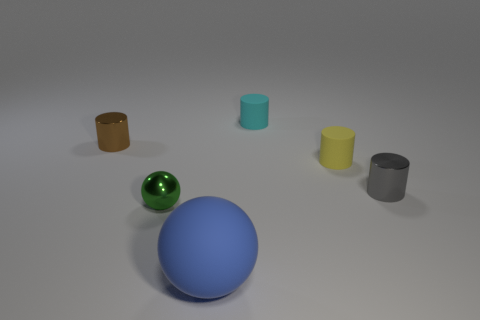Add 4 green objects. How many objects exist? 10 Subtract all spheres. How many objects are left? 4 Add 1 tiny gray metallic things. How many tiny gray metallic things exist? 2 Subtract 0 cyan cubes. How many objects are left? 6 Subtract all metal spheres. Subtract all green shiny blocks. How many objects are left? 5 Add 3 big balls. How many big balls are left? 4 